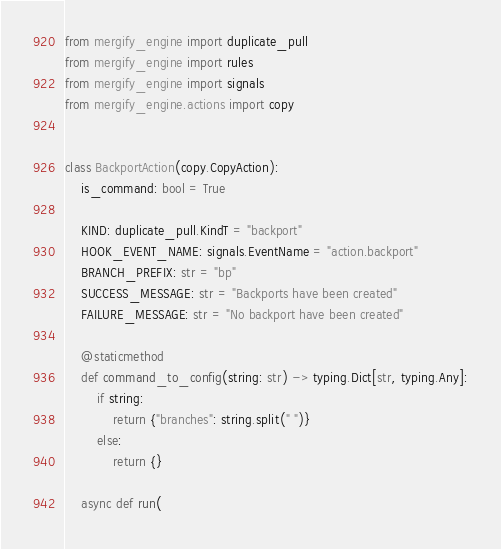<code> <loc_0><loc_0><loc_500><loc_500><_Python_>from mergify_engine import duplicate_pull
from mergify_engine import rules
from mergify_engine import signals
from mergify_engine.actions import copy


class BackportAction(copy.CopyAction):
    is_command: bool = True

    KIND: duplicate_pull.KindT = "backport"
    HOOK_EVENT_NAME: signals.EventName = "action.backport"
    BRANCH_PREFIX: str = "bp"
    SUCCESS_MESSAGE: str = "Backports have been created"
    FAILURE_MESSAGE: str = "No backport have been created"

    @staticmethod
    def command_to_config(string: str) -> typing.Dict[str, typing.Any]:
        if string:
            return {"branches": string.split(" ")}
        else:
            return {}

    async def run(</code> 